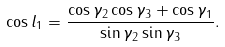<formula> <loc_0><loc_0><loc_500><loc_500>\cos l _ { 1 } = \frac { \cos \gamma _ { 2 } \cos \gamma _ { 3 } + \cos \gamma _ { 1 } } { \sin \gamma _ { 2 } \sin \gamma _ { 3 } } .</formula> 